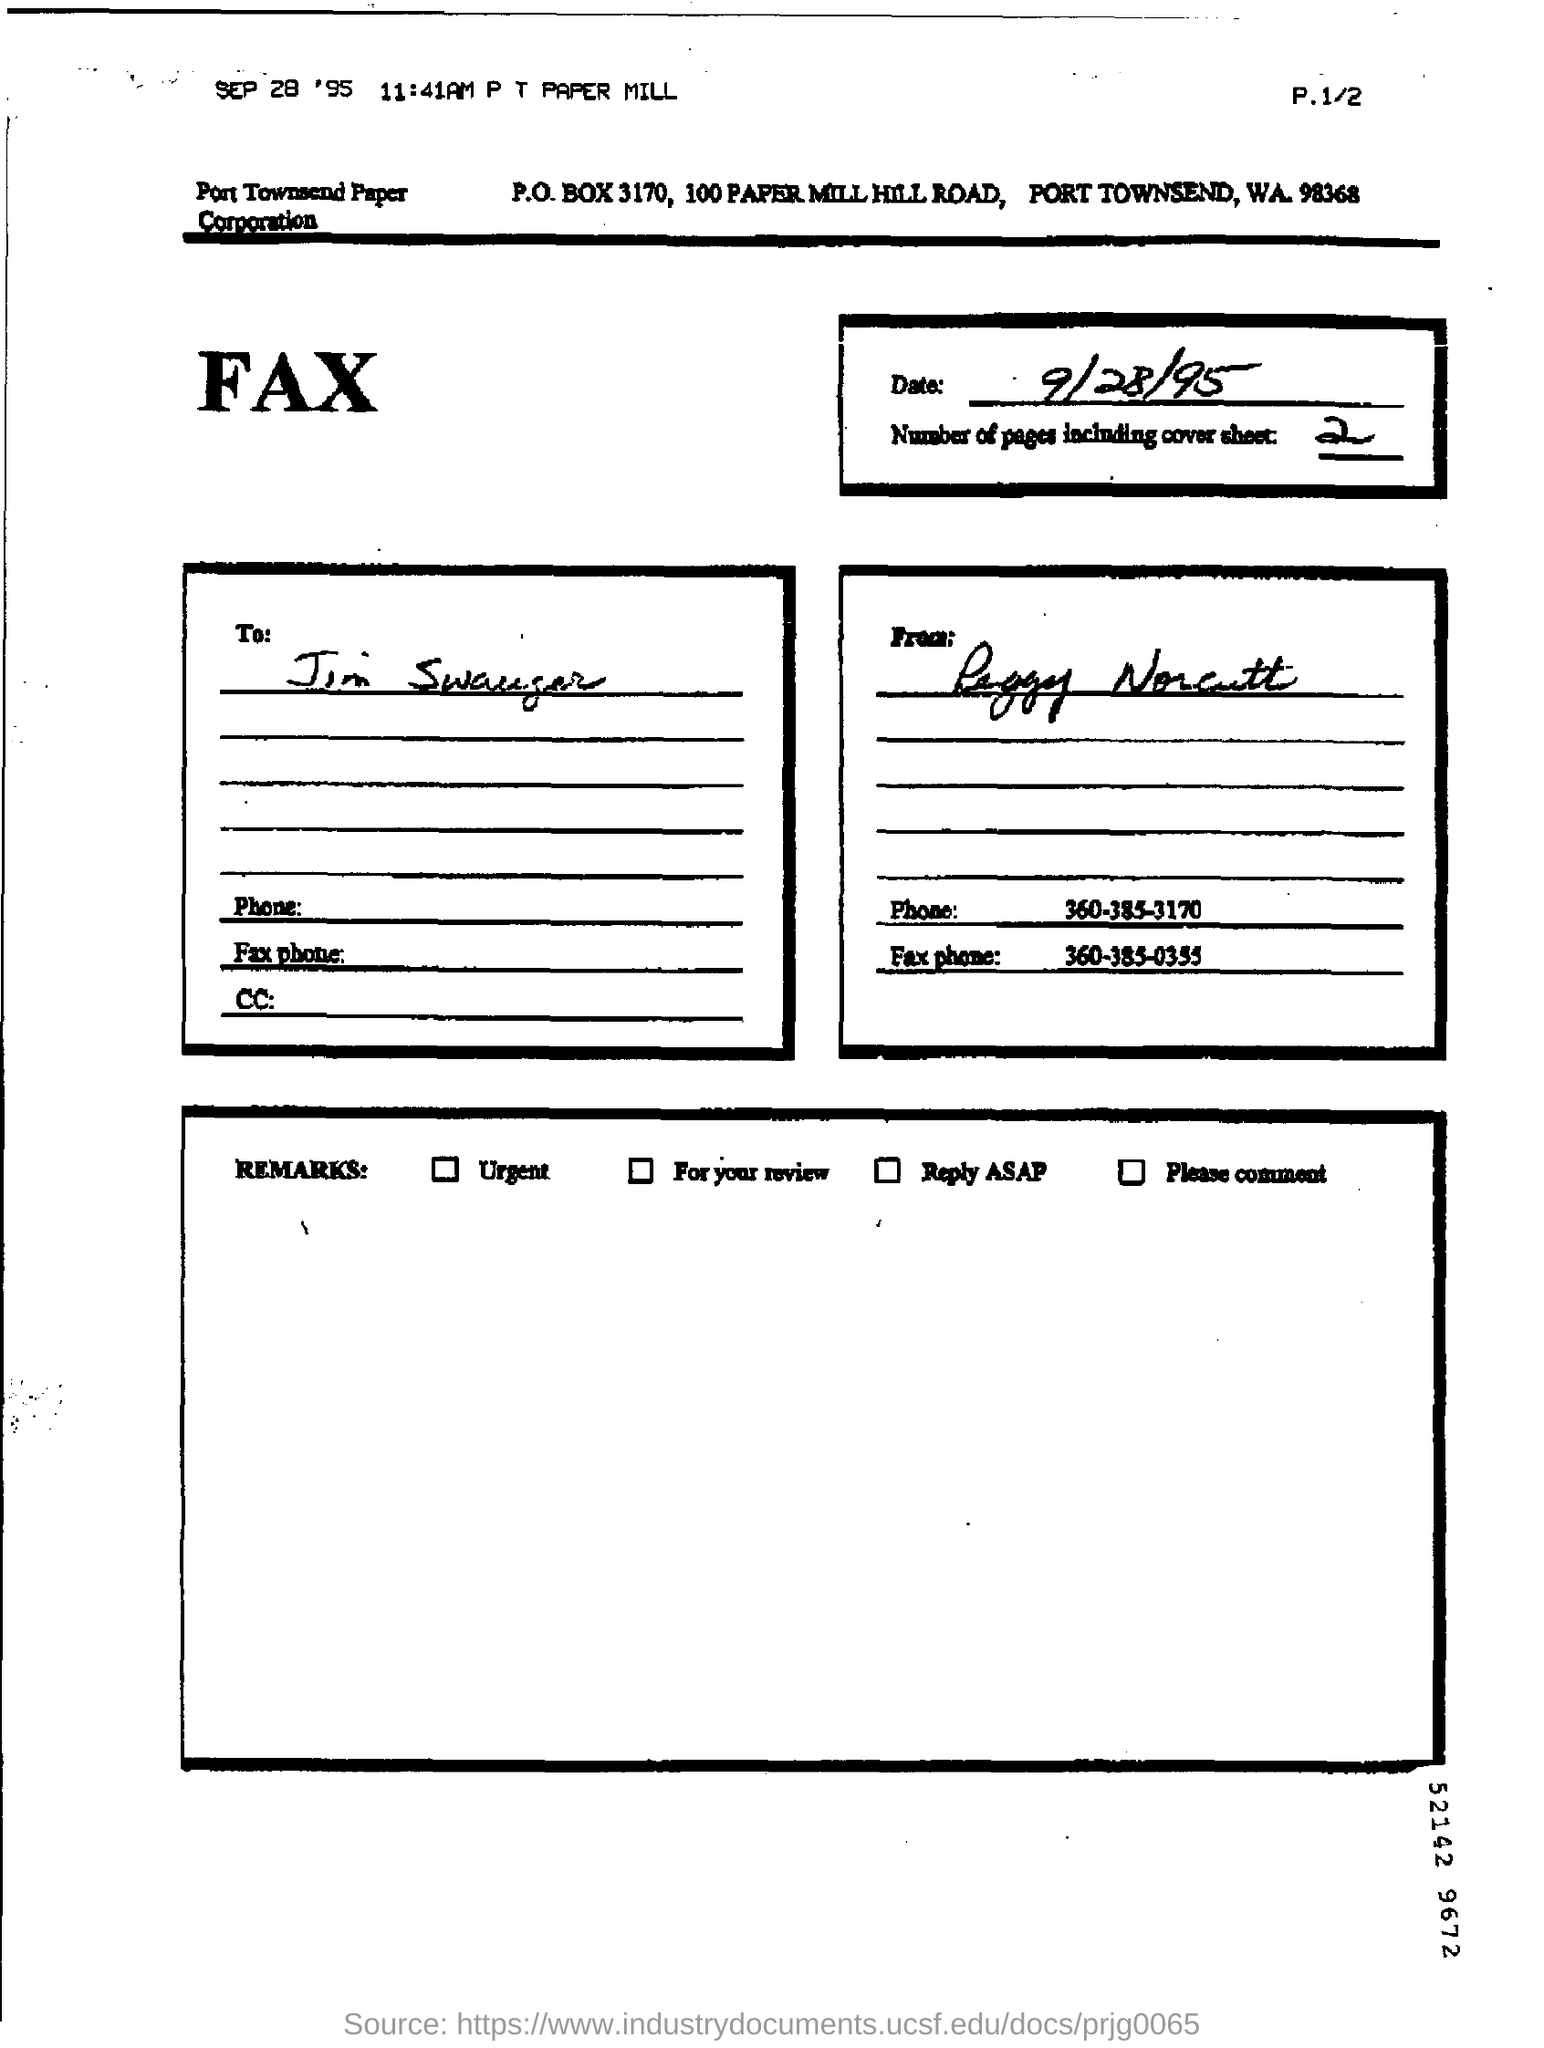How many number of pages are there including cover sheet ?
Offer a terse response. 2. What is the phone number mentioned in the fax ?
Your response must be concise. 360-385-3170. What is the fax phone number given ?
Offer a very short reply. 360-385-0355. What is the p.o.box number ?
Make the answer very short. 3170. 